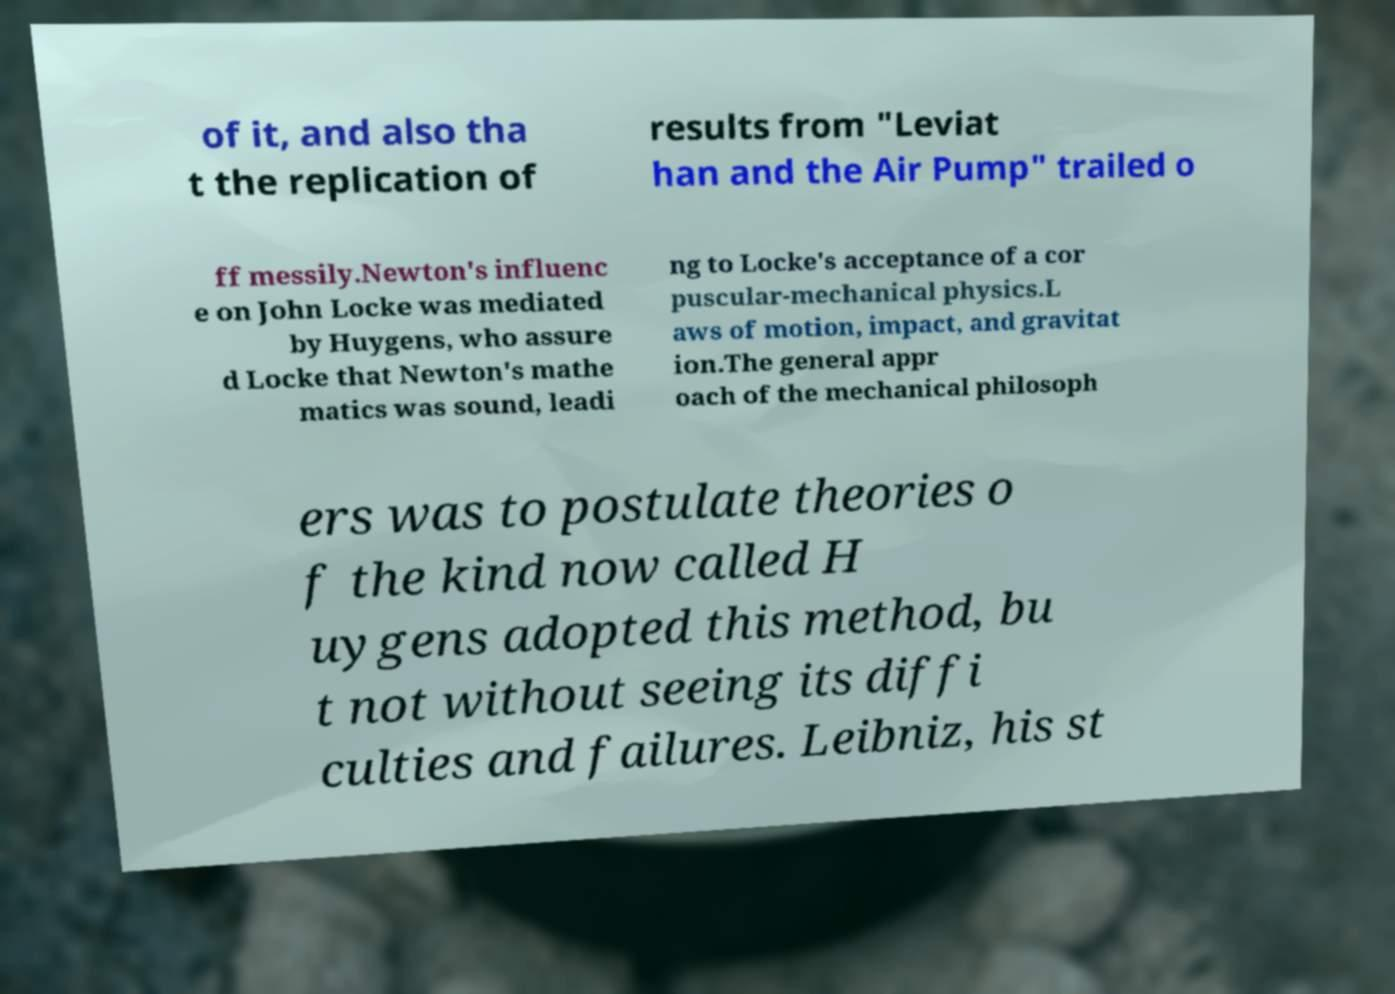Please read and relay the text visible in this image. What does it say? of it, and also tha t the replication of results from "Leviat han and the Air Pump" trailed o ff messily.Newton's influenc e on John Locke was mediated by Huygens, who assure d Locke that Newton's mathe matics was sound, leadi ng to Locke's acceptance of a cor puscular-mechanical physics.L aws of motion, impact, and gravitat ion.The general appr oach of the mechanical philosoph ers was to postulate theories o f the kind now called H uygens adopted this method, bu t not without seeing its diffi culties and failures. Leibniz, his st 